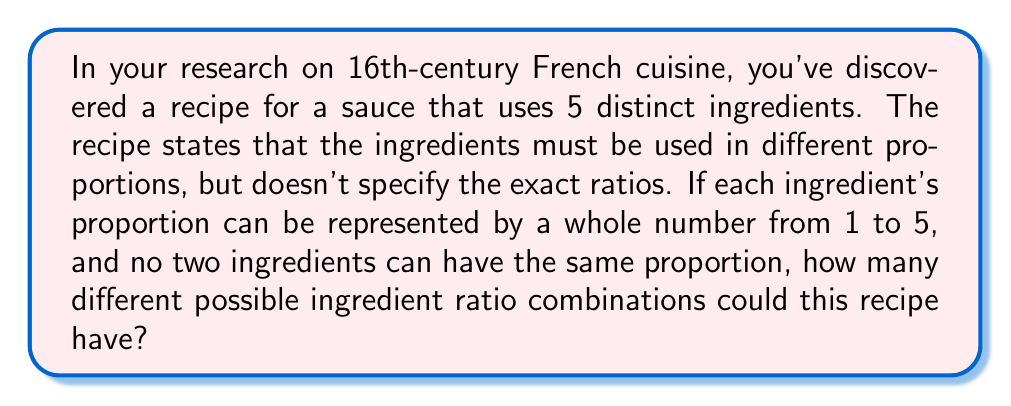Provide a solution to this math problem. Let's approach this step-by-step:

1) We have 5 ingredients, and each ingredient needs to be assigned a unique number from 1 to 5.

2) This is a permutation problem, as the order matters (different assignments of numbers to ingredients result in different ratios).

3) The number of permutations of n distinct objects is given by the formula:

   $$P(n) = n!$$

4) In this case, n = 5, so we need to calculate:

   $$P(5) = 5!$$

5) Let's expand this:

   $$5! = 5 \times 4 \times 3 \times 2 \times 1 = 120$$

6) Therefore, there are 120 different ways to assign the numbers 1 through 5 to the 5 ingredients, resulting in 120 different possible ratio combinations.
Answer: 120 